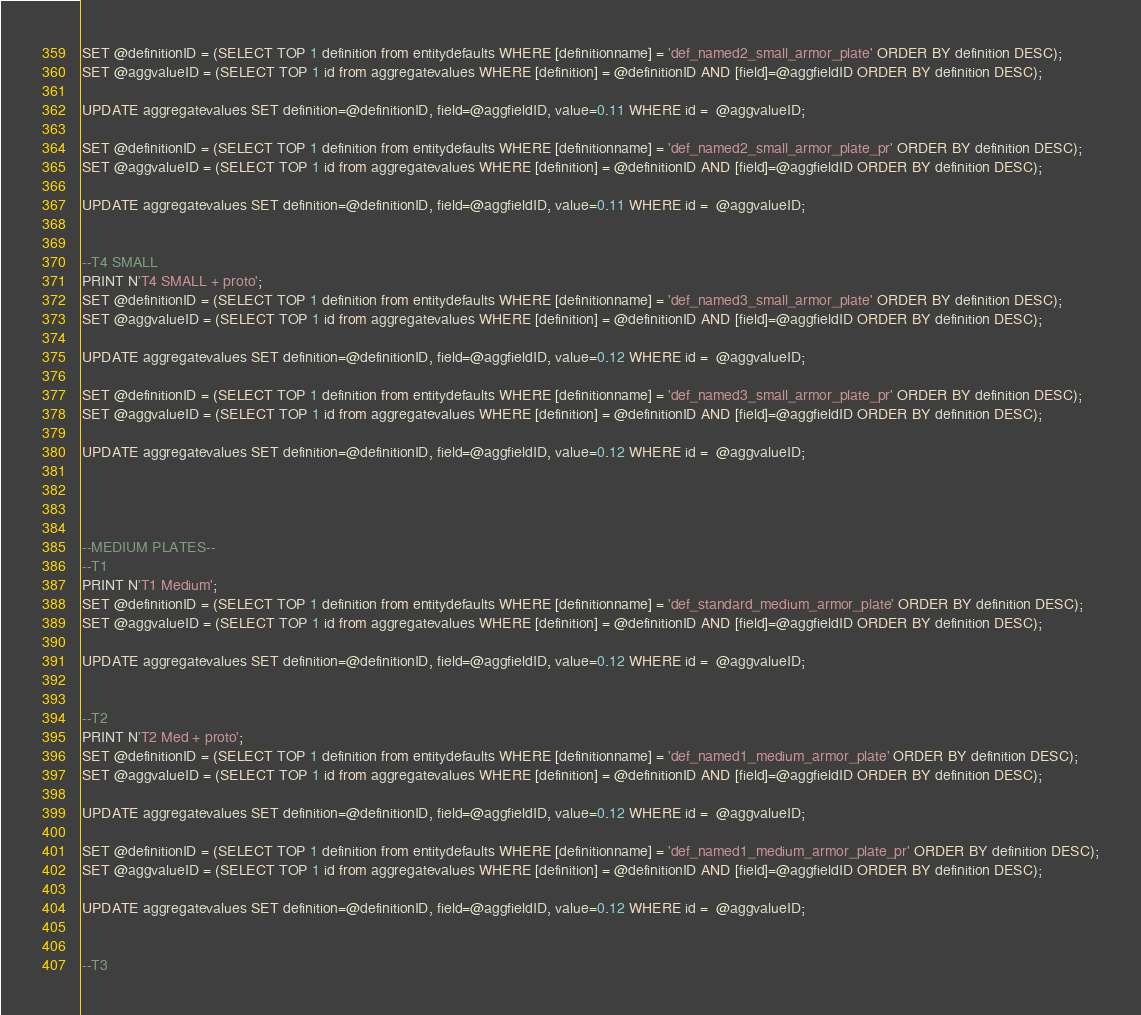Convert code to text. <code><loc_0><loc_0><loc_500><loc_500><_SQL_>SET @definitionID = (SELECT TOP 1 definition from entitydefaults WHERE [definitionname] = 'def_named2_small_armor_plate' ORDER BY definition DESC);
SET @aggvalueID = (SELECT TOP 1 id from aggregatevalues WHERE [definition] = @definitionID AND [field]=@aggfieldID ORDER BY definition DESC);

UPDATE aggregatevalues SET definition=@definitionID, field=@aggfieldID, value=0.11 WHERE id =  @aggvalueID;

SET @definitionID = (SELECT TOP 1 definition from entitydefaults WHERE [definitionname] = 'def_named2_small_armor_plate_pr' ORDER BY definition DESC);
SET @aggvalueID = (SELECT TOP 1 id from aggregatevalues WHERE [definition] = @definitionID AND [field]=@aggfieldID ORDER BY definition DESC);

UPDATE aggregatevalues SET definition=@definitionID, field=@aggfieldID, value=0.11 WHERE id =  @aggvalueID;


--T4 SMALL
PRINT N'T4 SMALL + proto';
SET @definitionID = (SELECT TOP 1 definition from entitydefaults WHERE [definitionname] = 'def_named3_small_armor_plate' ORDER BY definition DESC);
SET @aggvalueID = (SELECT TOP 1 id from aggregatevalues WHERE [definition] = @definitionID AND [field]=@aggfieldID ORDER BY definition DESC);

UPDATE aggregatevalues SET definition=@definitionID, field=@aggfieldID, value=0.12 WHERE id =  @aggvalueID;

SET @definitionID = (SELECT TOP 1 definition from entitydefaults WHERE [definitionname] = 'def_named3_small_armor_plate_pr' ORDER BY definition DESC);
SET @aggvalueID = (SELECT TOP 1 id from aggregatevalues WHERE [definition] = @definitionID AND [field]=@aggfieldID ORDER BY definition DESC);

UPDATE aggregatevalues SET definition=@definitionID, field=@aggfieldID, value=0.12 WHERE id =  @aggvalueID;




--MEDIUM PLATES--
--T1
PRINT N'T1 Medium';
SET @definitionID = (SELECT TOP 1 definition from entitydefaults WHERE [definitionname] = 'def_standard_medium_armor_plate' ORDER BY definition DESC);
SET @aggvalueID = (SELECT TOP 1 id from aggregatevalues WHERE [definition] = @definitionID AND [field]=@aggfieldID ORDER BY definition DESC);

UPDATE aggregatevalues SET definition=@definitionID, field=@aggfieldID, value=0.12 WHERE id =  @aggvalueID;


--T2
PRINT N'T2 Med + proto';
SET @definitionID = (SELECT TOP 1 definition from entitydefaults WHERE [definitionname] = 'def_named1_medium_armor_plate' ORDER BY definition DESC);
SET @aggvalueID = (SELECT TOP 1 id from aggregatevalues WHERE [definition] = @definitionID AND [field]=@aggfieldID ORDER BY definition DESC);

UPDATE aggregatevalues SET definition=@definitionID, field=@aggfieldID, value=0.12 WHERE id =  @aggvalueID;

SET @definitionID = (SELECT TOP 1 definition from entitydefaults WHERE [definitionname] = 'def_named1_medium_armor_plate_pr' ORDER BY definition DESC);
SET @aggvalueID = (SELECT TOP 1 id from aggregatevalues WHERE [definition] = @definitionID AND [field]=@aggfieldID ORDER BY definition DESC);

UPDATE aggregatevalues SET definition=@definitionID, field=@aggfieldID, value=0.12 WHERE id =  @aggvalueID;


--T3</code> 